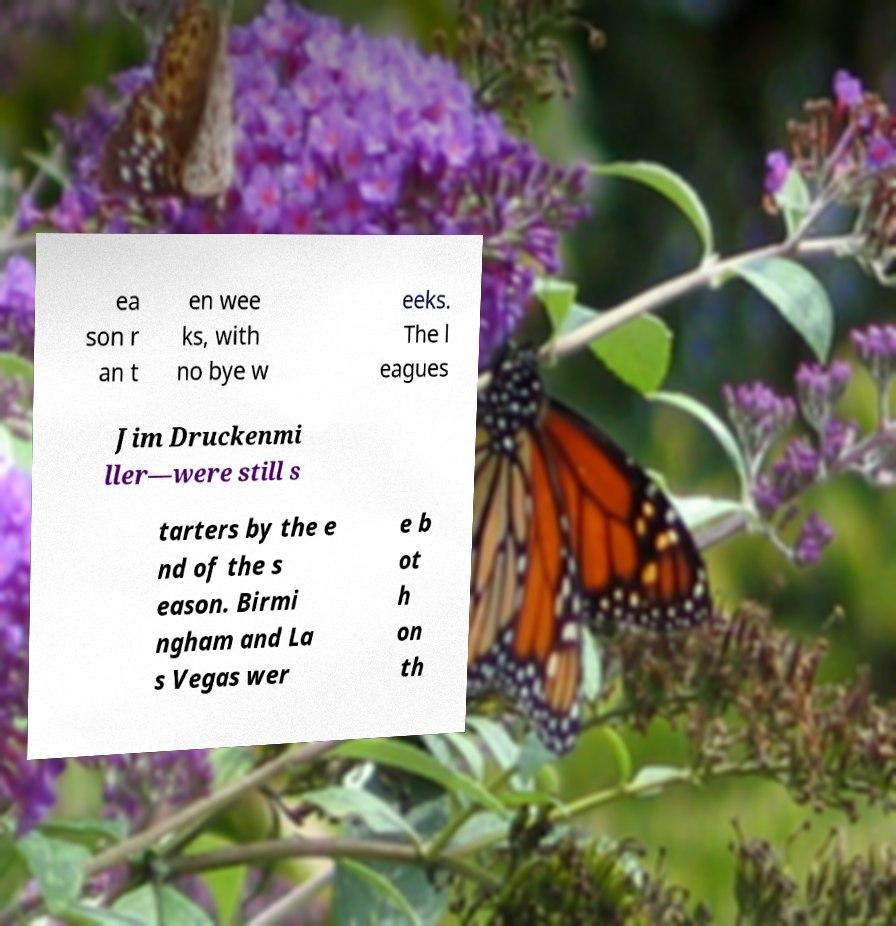Please read and relay the text visible in this image. What does it say? ea son r an t en wee ks, with no bye w eeks. The l eagues Jim Druckenmi ller—were still s tarters by the e nd of the s eason. Birmi ngham and La s Vegas wer e b ot h on th 